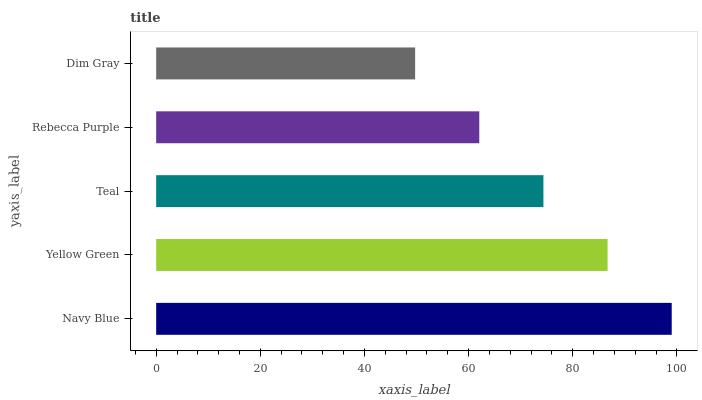Is Dim Gray the minimum?
Answer yes or no. Yes. Is Navy Blue the maximum?
Answer yes or no. Yes. Is Yellow Green the minimum?
Answer yes or no. No. Is Yellow Green the maximum?
Answer yes or no. No. Is Navy Blue greater than Yellow Green?
Answer yes or no. Yes. Is Yellow Green less than Navy Blue?
Answer yes or no. Yes. Is Yellow Green greater than Navy Blue?
Answer yes or no. No. Is Navy Blue less than Yellow Green?
Answer yes or no. No. Is Teal the high median?
Answer yes or no. Yes. Is Teal the low median?
Answer yes or no. Yes. Is Dim Gray the high median?
Answer yes or no. No. Is Navy Blue the low median?
Answer yes or no. No. 